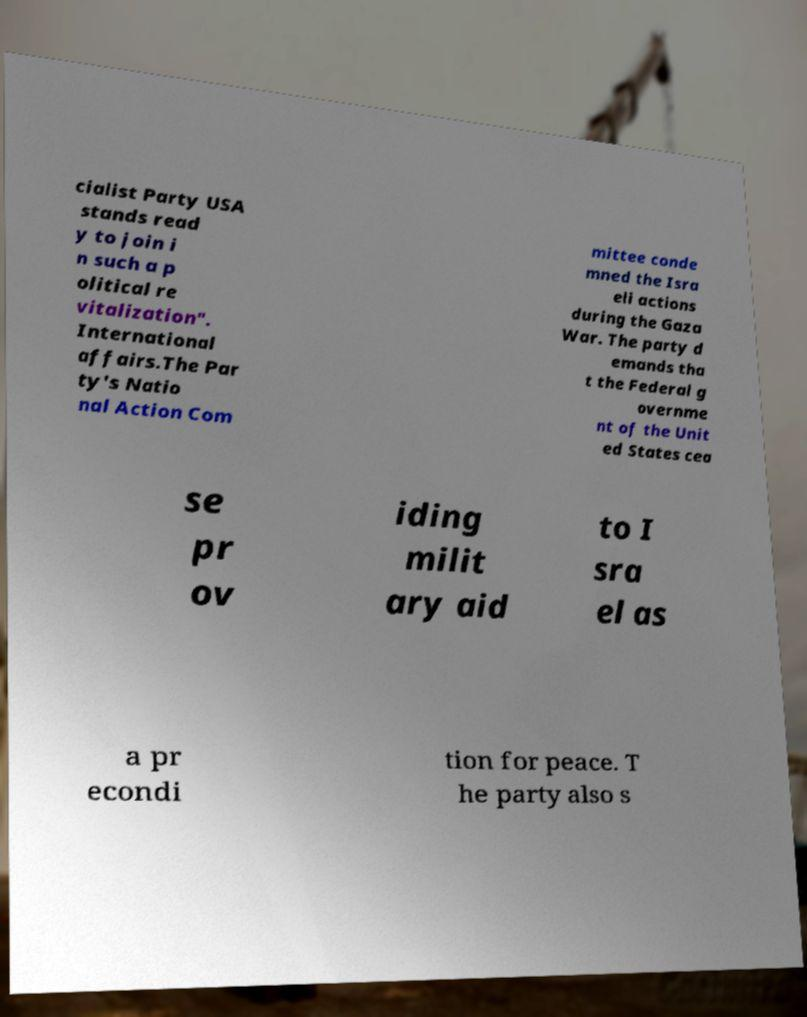Could you extract and type out the text from this image? cialist Party USA stands read y to join i n such a p olitical re vitalization". International affairs.The Par ty's Natio nal Action Com mittee conde mned the Isra eli actions during the Gaza War. The party d emands tha t the Federal g overnme nt of the Unit ed States cea se pr ov iding milit ary aid to I sra el as a pr econdi tion for peace. T he party also s 